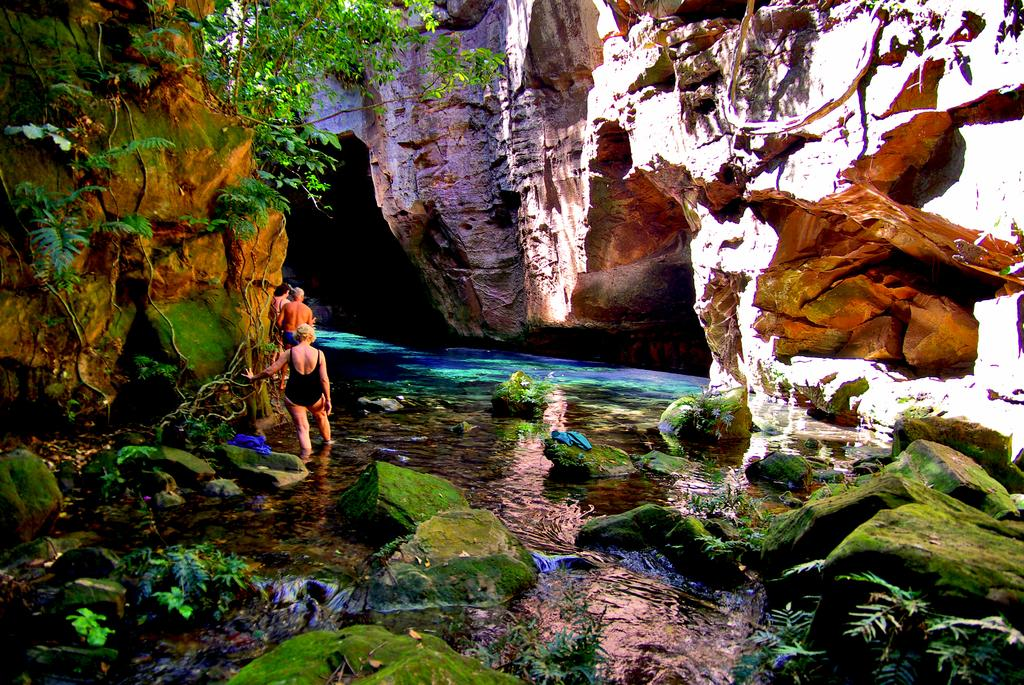Who or what is present in the image? There are people in the image. What type of natural elements can be seen in the image? There are rocks and trees in the image. How many spiders are visible on the rocks in the image? There are no spiders visible on the rocks in the image. What type of writing instrument is being used by the people in the image? There is no mention of a pencil or any writing instrument being used by the people in the image. 